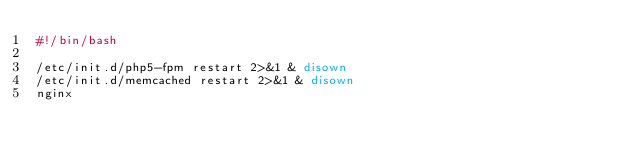<code> <loc_0><loc_0><loc_500><loc_500><_Bash_>#!/bin/bash

/etc/init.d/php5-fpm restart 2>&1 & disown
/etc/init.d/memcached restart 2>&1 & disown
nginx

</code> 